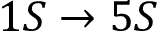Convert formula to latex. <formula><loc_0><loc_0><loc_500><loc_500>1 S \rightarrow 5 S</formula> 